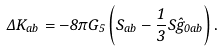Convert formula to latex. <formula><loc_0><loc_0><loc_500><loc_500>\Delta K _ { a b } = - 8 \pi G _ { 5 } \left ( S _ { a b } - \frac { 1 } { 3 } S \hat { g } _ { 0 a b } \right ) .</formula> 